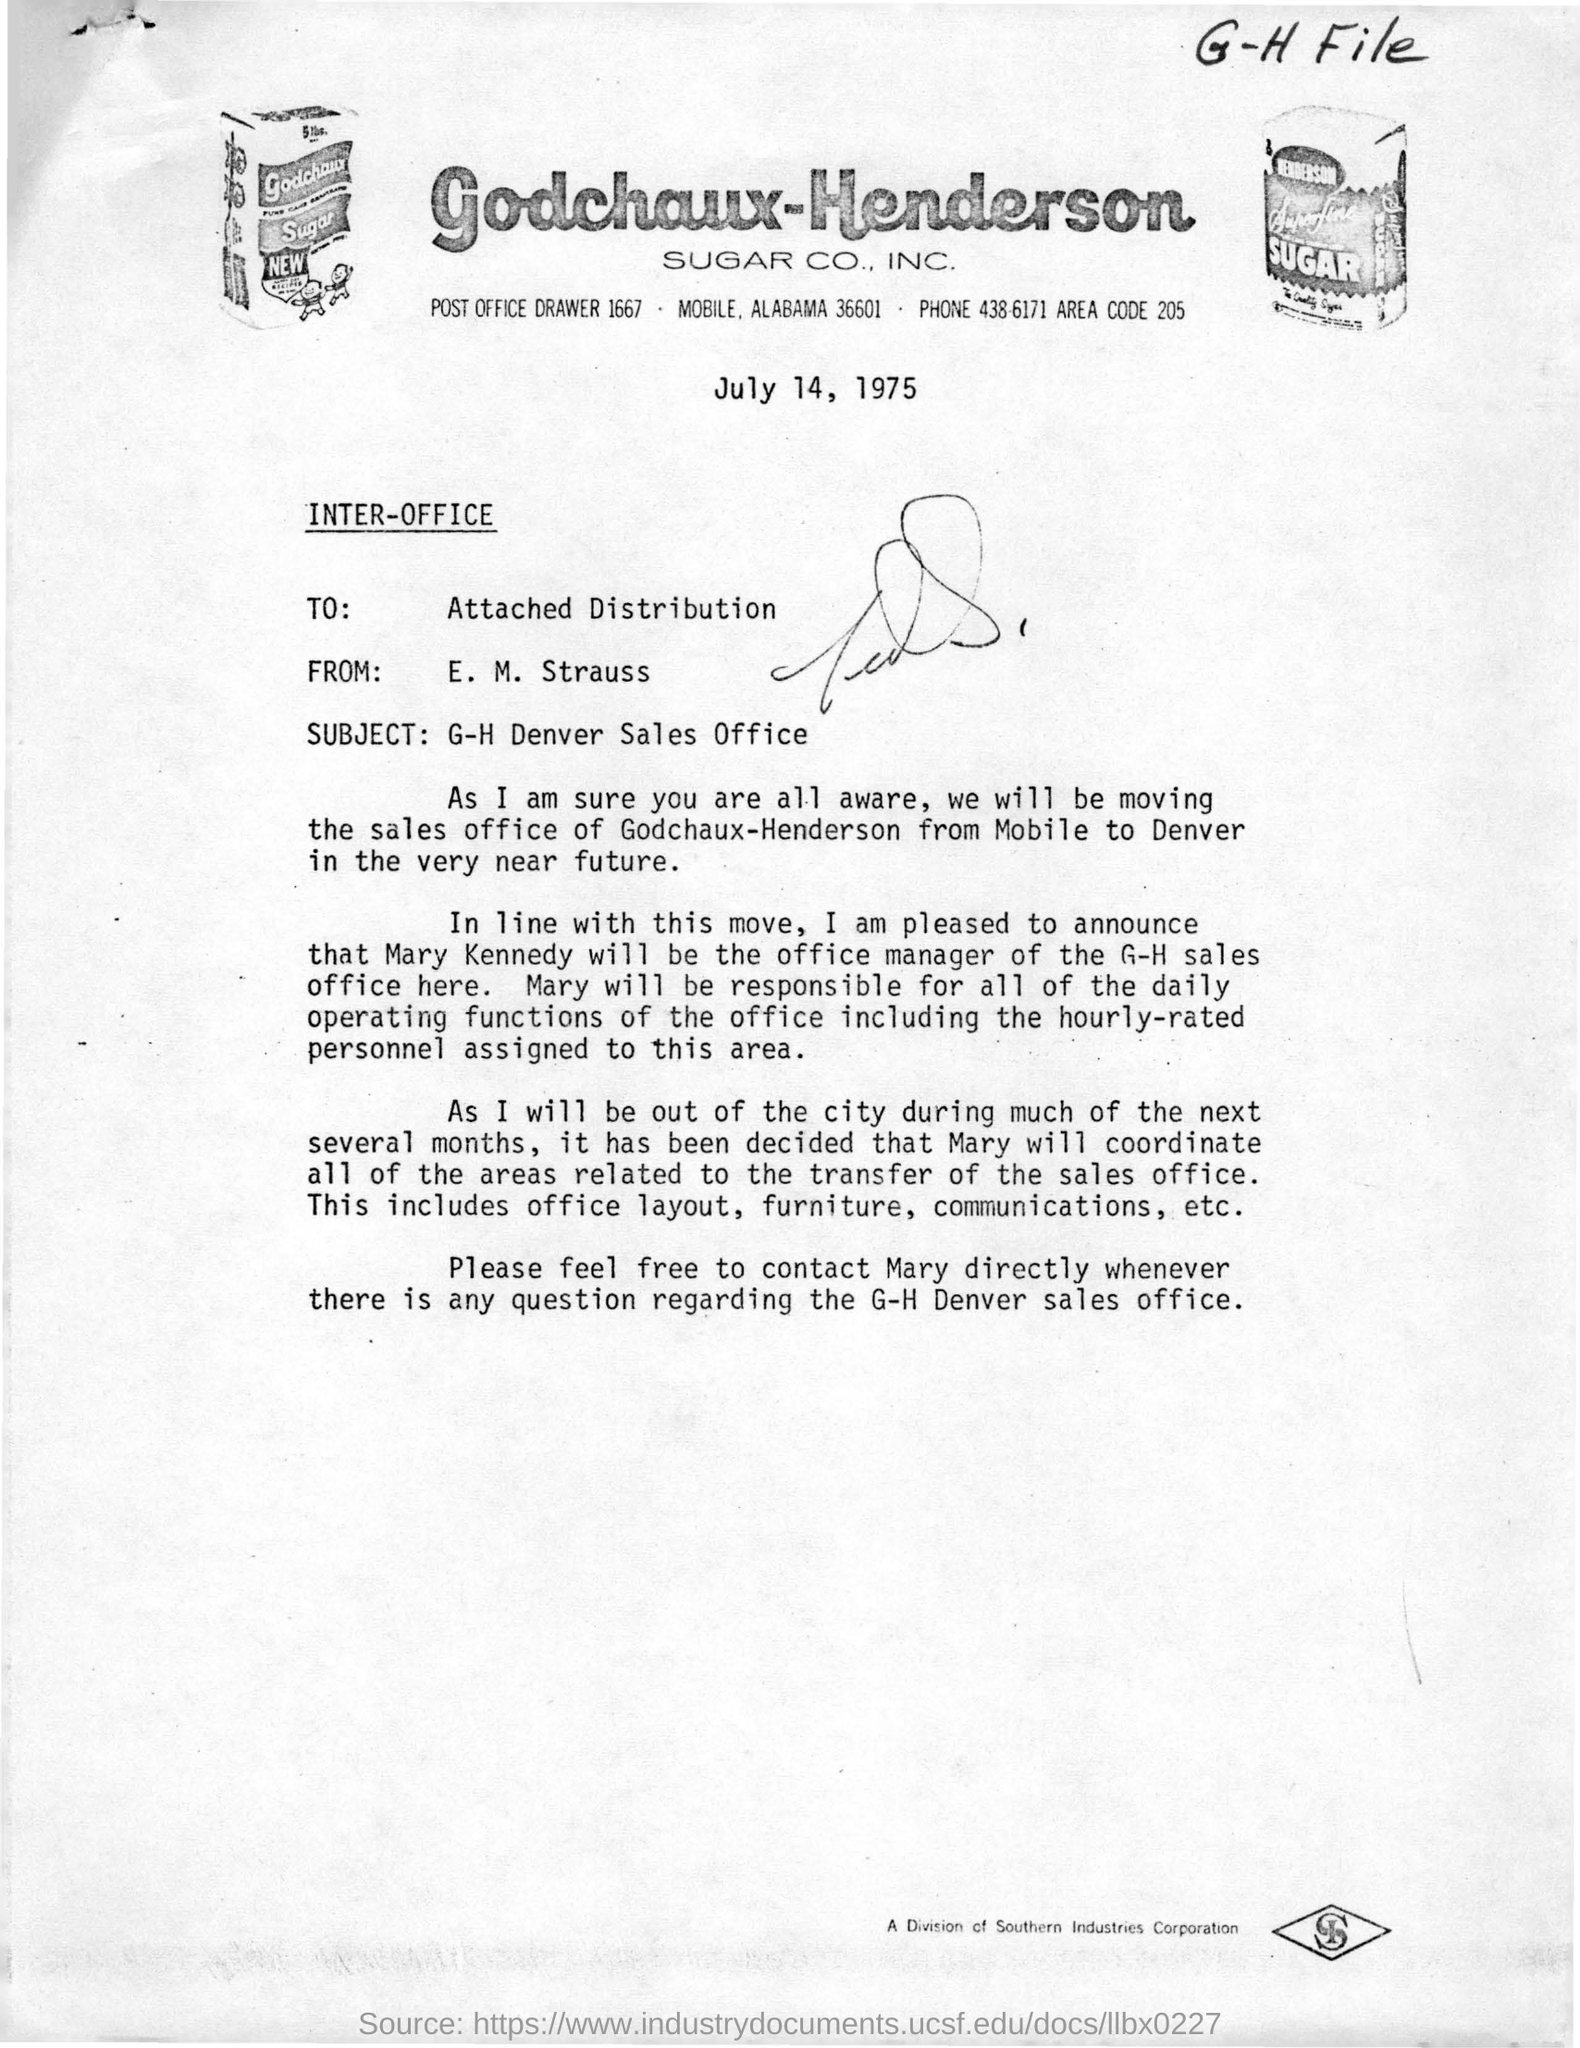Give some essential details in this illustration. Godchaux-Henderson's sales office will be moving to Denver. The memorandum is from E. M. Strauss. The office manager of the G-H sales office will be Mary Kennedy. The area code for Godchaux-Henderson Sugar CO, INC. is 205. 